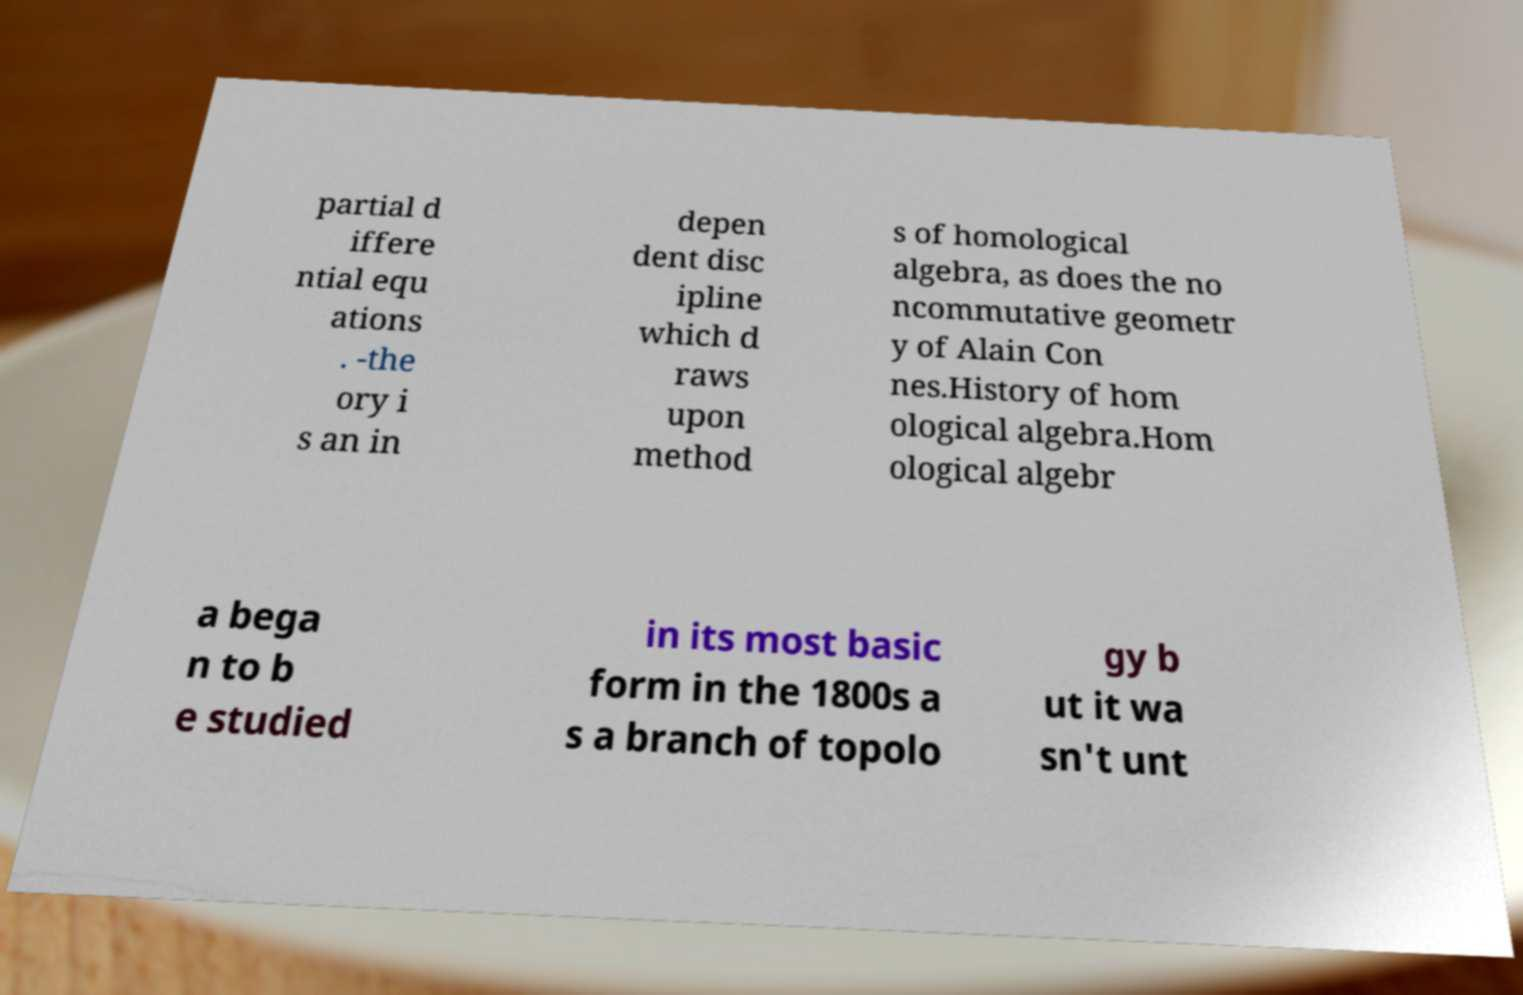Could you extract and type out the text from this image? partial d iffere ntial equ ations . -the ory i s an in depen dent disc ipline which d raws upon method s of homological algebra, as does the no ncommutative geometr y of Alain Con nes.History of hom ological algebra.Hom ological algebr a bega n to b e studied in its most basic form in the 1800s a s a branch of topolo gy b ut it wa sn't unt 